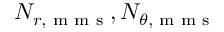<formula> <loc_0><loc_0><loc_500><loc_500>N _ { r , m m s } , N _ { \theta , m m s }</formula> 